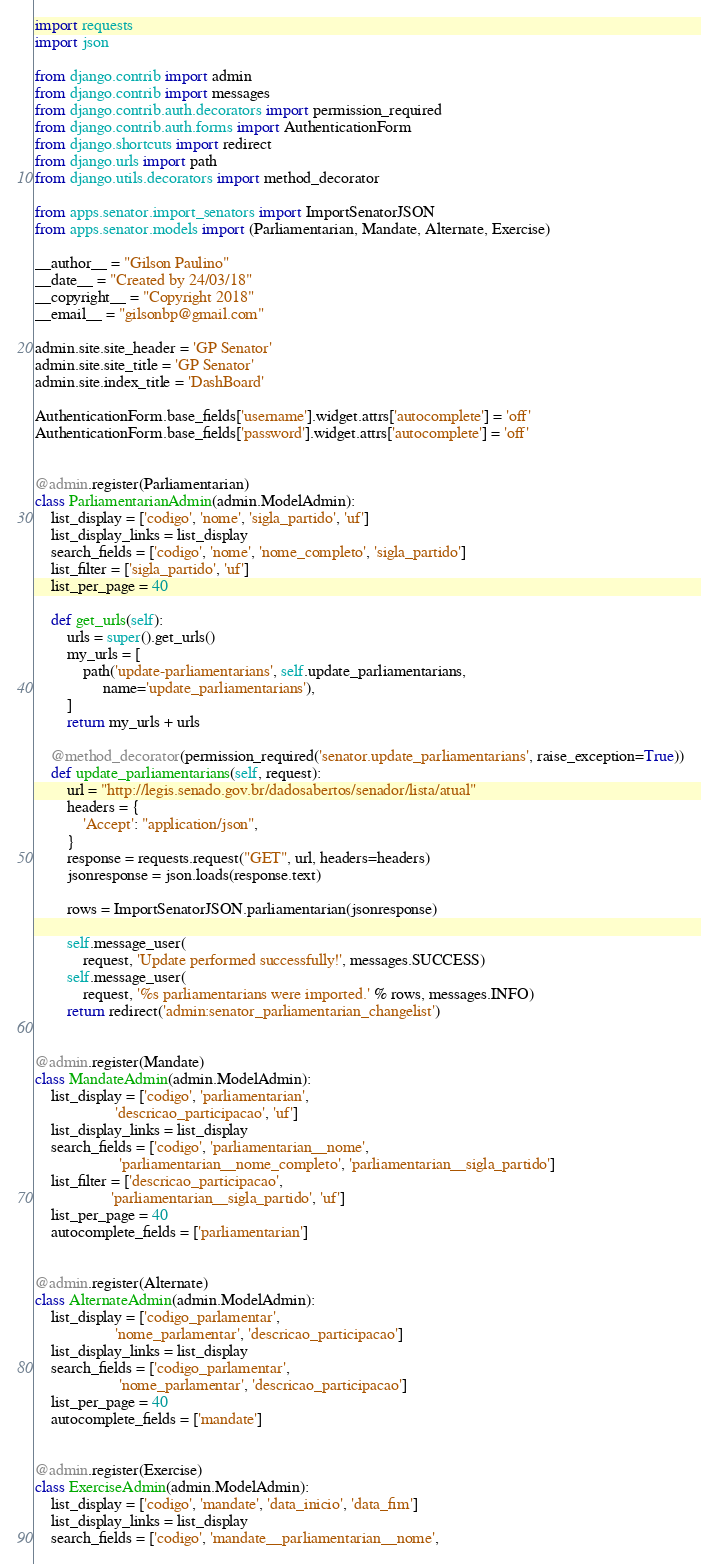<code> <loc_0><loc_0><loc_500><loc_500><_Python_>import requests
import json

from django.contrib import admin
from django.contrib import messages
from django.contrib.auth.decorators import permission_required
from django.contrib.auth.forms import AuthenticationForm
from django.shortcuts import redirect
from django.urls import path
from django.utils.decorators import method_decorator

from apps.senator.import_senators import ImportSenatorJSON
from apps.senator.models import (Parliamentarian, Mandate, Alternate, Exercise)

__author__ = "Gilson Paulino"
__date__ = "Created by 24/03/18"
__copyright__ = "Copyright 2018"
__email__ = "gilsonbp@gmail.com"

admin.site.site_header = 'GP Senator'
admin.site.site_title = 'GP Senator'
admin.site.index_title = 'DashBoard'

AuthenticationForm.base_fields['username'].widget.attrs['autocomplete'] = 'off'
AuthenticationForm.base_fields['password'].widget.attrs['autocomplete'] = 'off'


@admin.register(Parliamentarian)
class ParliamentarianAdmin(admin.ModelAdmin):
    list_display = ['codigo', 'nome', 'sigla_partido', 'uf']
    list_display_links = list_display
    search_fields = ['codigo', 'nome', 'nome_completo', 'sigla_partido']
    list_filter = ['sigla_partido', 'uf']
    list_per_page = 40

    def get_urls(self):
        urls = super().get_urls()
        my_urls = [
            path('update-parliamentarians', self.update_parliamentarians,
                 name='update_parliamentarians'),
        ]
        return my_urls + urls

    @method_decorator(permission_required('senator.update_parliamentarians', raise_exception=True))
    def update_parliamentarians(self, request):
        url = "http://legis.senado.gov.br/dadosabertos/senador/lista/atual"
        headers = {
            'Accept': "application/json",
        }
        response = requests.request("GET", url, headers=headers)
        jsonresponse = json.loads(response.text)

        rows = ImportSenatorJSON.parliamentarian(jsonresponse)

        self.message_user(
            request, 'Update performed successfully!', messages.SUCCESS)
        self.message_user(
            request, '%s parliamentarians were imported.' % rows, messages.INFO)
        return redirect('admin:senator_parliamentarian_changelist')


@admin.register(Mandate)
class MandateAdmin(admin.ModelAdmin):
    list_display = ['codigo', 'parliamentarian',
                    'descricao_participacao', 'uf']
    list_display_links = list_display
    search_fields = ['codigo', 'parliamentarian__nome',
                     'parliamentarian__nome_completo', 'parliamentarian__sigla_partido']
    list_filter = ['descricao_participacao',
                   'parliamentarian__sigla_partido', 'uf']
    list_per_page = 40
    autocomplete_fields = ['parliamentarian']


@admin.register(Alternate)
class AlternateAdmin(admin.ModelAdmin):
    list_display = ['codigo_parlamentar',
                    'nome_parlamentar', 'descricao_participacao']
    list_display_links = list_display
    search_fields = ['codigo_parlamentar',
                     'nome_parlamentar', 'descricao_participacao']
    list_per_page = 40
    autocomplete_fields = ['mandate']


@admin.register(Exercise)
class ExerciseAdmin(admin.ModelAdmin):
    list_display = ['codigo', 'mandate', 'data_inicio', 'data_fim']
    list_display_links = list_display
    search_fields = ['codigo', 'mandate__parliamentarian__nome',</code> 